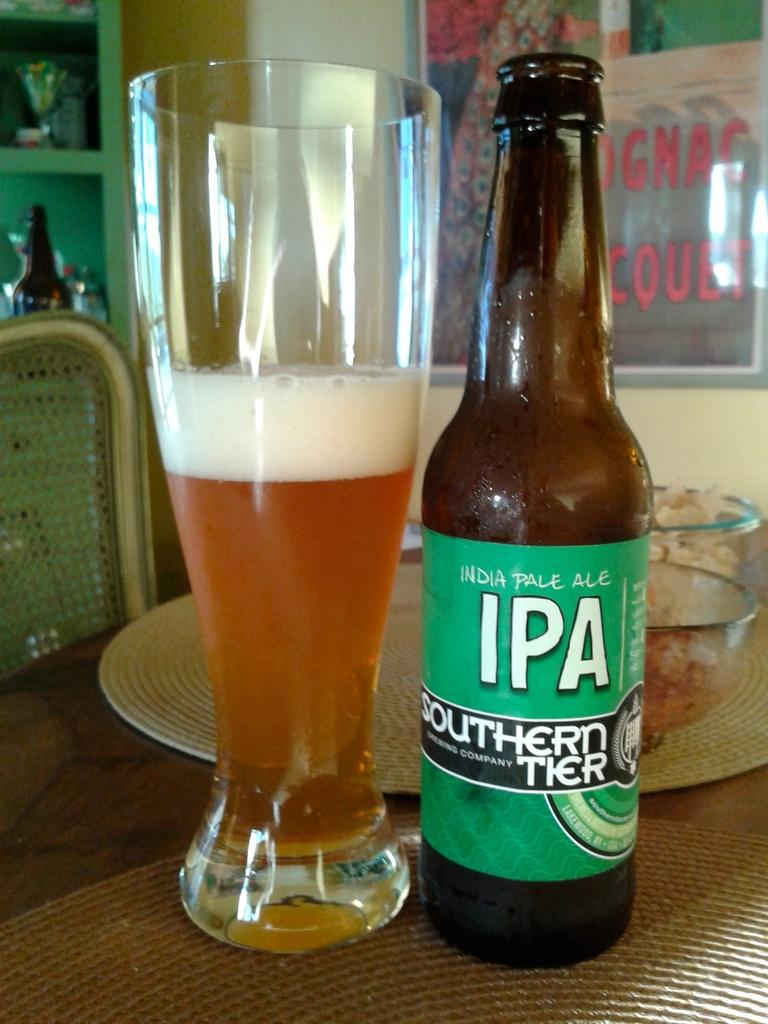<image>
Present a compact description of the photo's key features. A bottle of Southern Tier IPA beer sits next to a half full glass. 